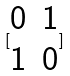Convert formula to latex. <formula><loc_0><loc_0><loc_500><loc_500>[ \begin{matrix} 0 & 1 \\ 1 & 0 \end{matrix} ]</formula> 